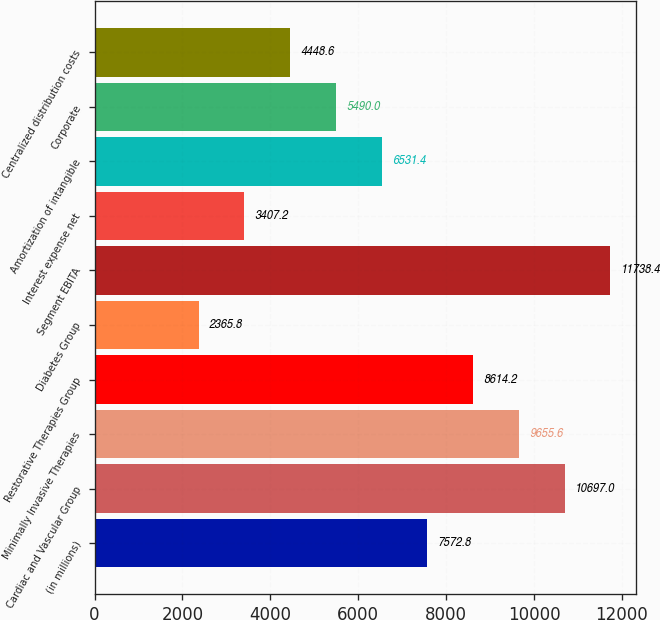<chart> <loc_0><loc_0><loc_500><loc_500><bar_chart><fcel>(in millions)<fcel>Cardiac and Vascular Group<fcel>Minimally Invasive Therapies<fcel>Restorative Therapies Group<fcel>Diabetes Group<fcel>Segment EBITA<fcel>Interest expense net<fcel>Amortization of intangible<fcel>Corporate<fcel>Centralized distribution costs<nl><fcel>7572.8<fcel>10697<fcel>9655.6<fcel>8614.2<fcel>2365.8<fcel>11738.4<fcel>3407.2<fcel>6531.4<fcel>5490<fcel>4448.6<nl></chart> 